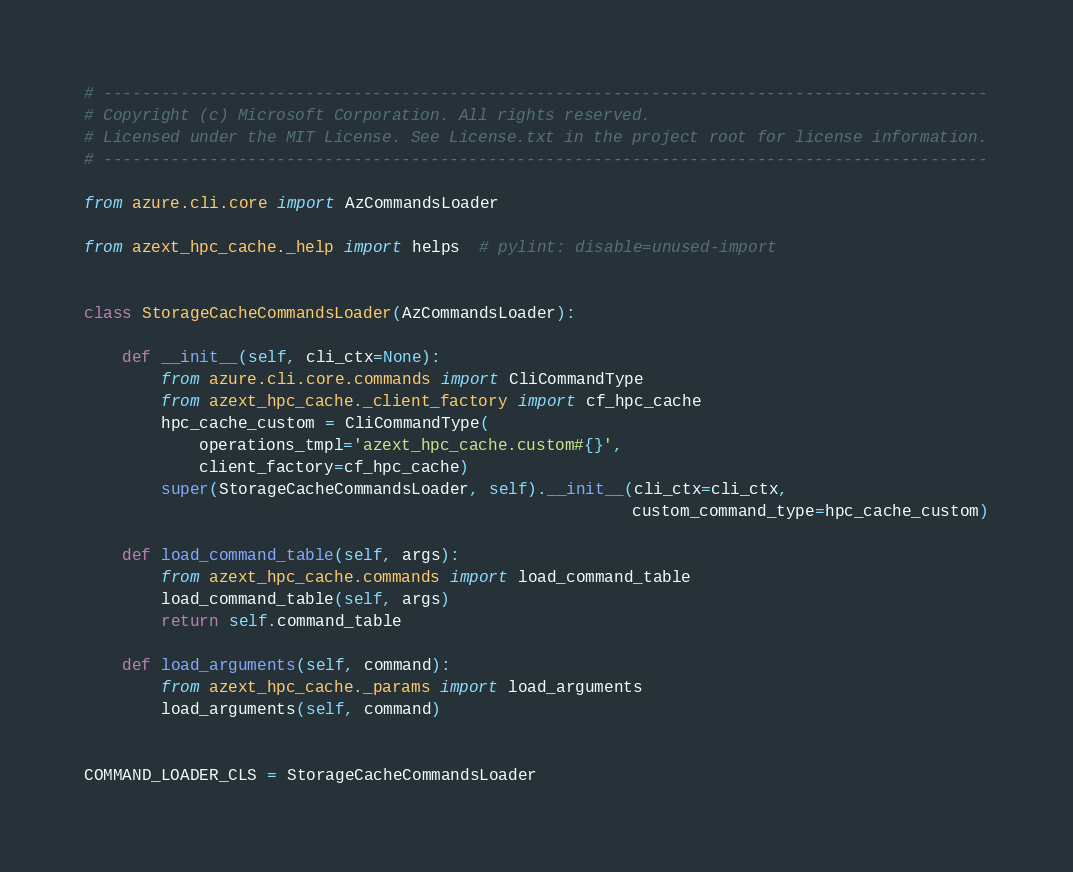<code> <loc_0><loc_0><loc_500><loc_500><_Python_># --------------------------------------------------------------------------------------------
# Copyright (c) Microsoft Corporation. All rights reserved.
# Licensed under the MIT License. See License.txt in the project root for license information.
# --------------------------------------------------------------------------------------------

from azure.cli.core import AzCommandsLoader

from azext_hpc_cache._help import helps  # pylint: disable=unused-import


class StorageCacheCommandsLoader(AzCommandsLoader):

    def __init__(self, cli_ctx=None):
        from azure.cli.core.commands import CliCommandType
        from azext_hpc_cache._client_factory import cf_hpc_cache
        hpc_cache_custom = CliCommandType(
            operations_tmpl='azext_hpc_cache.custom#{}',
            client_factory=cf_hpc_cache)
        super(StorageCacheCommandsLoader, self).__init__(cli_ctx=cli_ctx,
                                                         custom_command_type=hpc_cache_custom)

    def load_command_table(self, args):
        from azext_hpc_cache.commands import load_command_table
        load_command_table(self, args)
        return self.command_table

    def load_arguments(self, command):
        from azext_hpc_cache._params import load_arguments
        load_arguments(self, command)


COMMAND_LOADER_CLS = StorageCacheCommandsLoader
</code> 